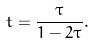Convert formula to latex. <formula><loc_0><loc_0><loc_500><loc_500>t = \frac { \tau } { 1 - 2 \tau } .</formula> 